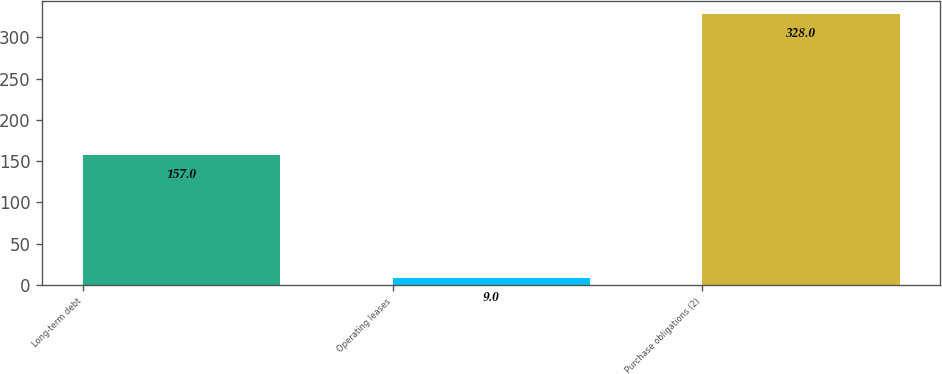Convert chart. <chart><loc_0><loc_0><loc_500><loc_500><bar_chart><fcel>Long-term debt<fcel>Operating leases<fcel>Purchase obligations (2)<nl><fcel>157<fcel>9<fcel>328<nl></chart> 